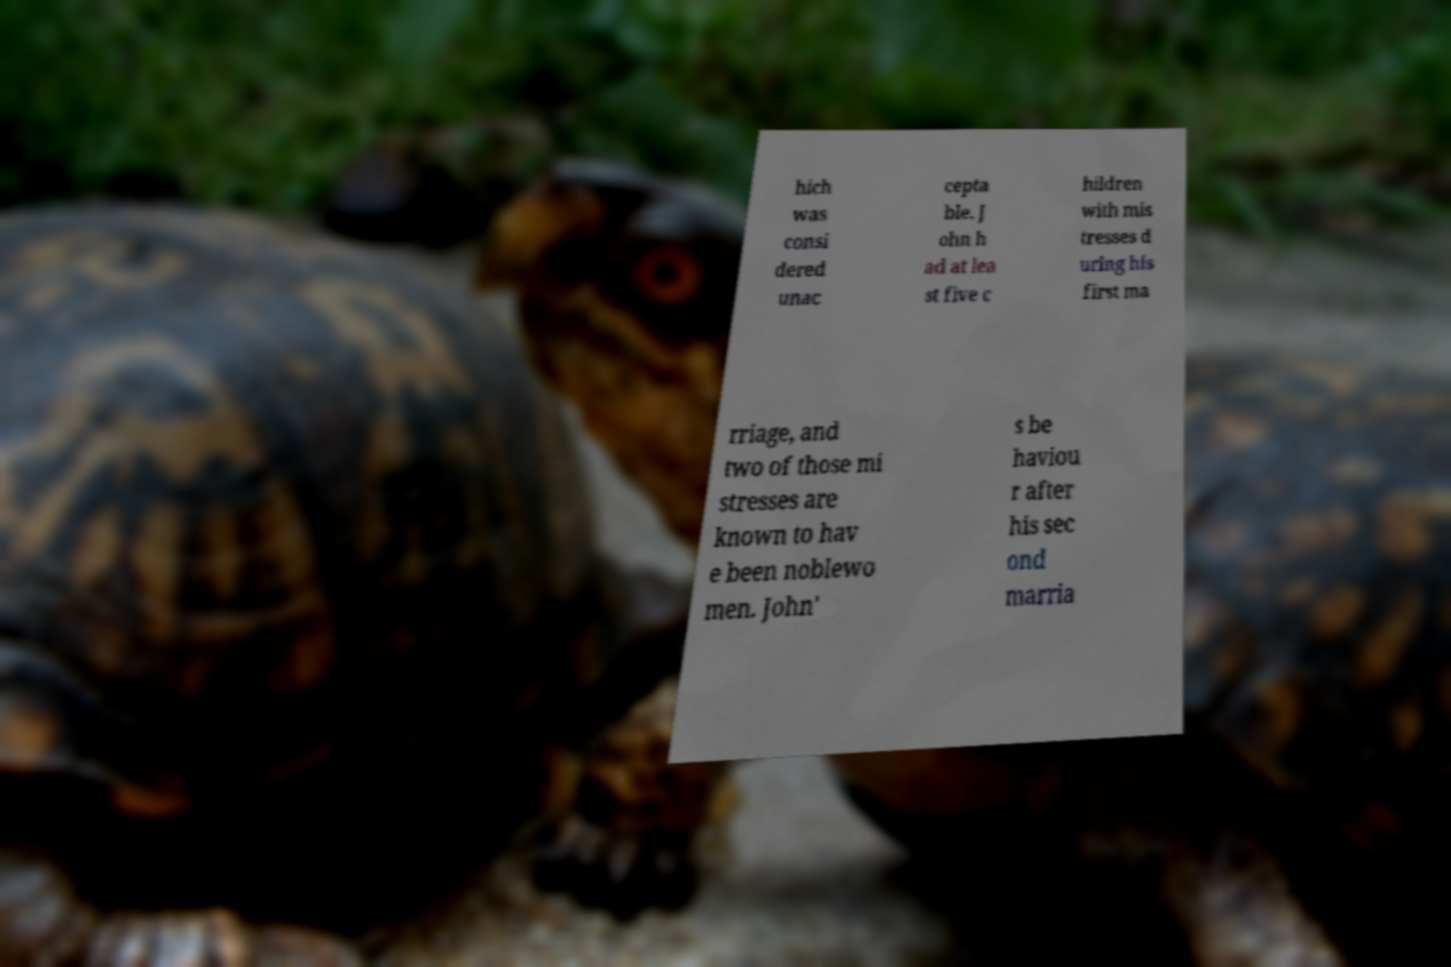Could you extract and type out the text from this image? hich was consi dered unac cepta ble. J ohn h ad at lea st five c hildren with mis tresses d uring his first ma rriage, and two of those mi stresses are known to hav e been noblewo men. John' s be haviou r after his sec ond marria 